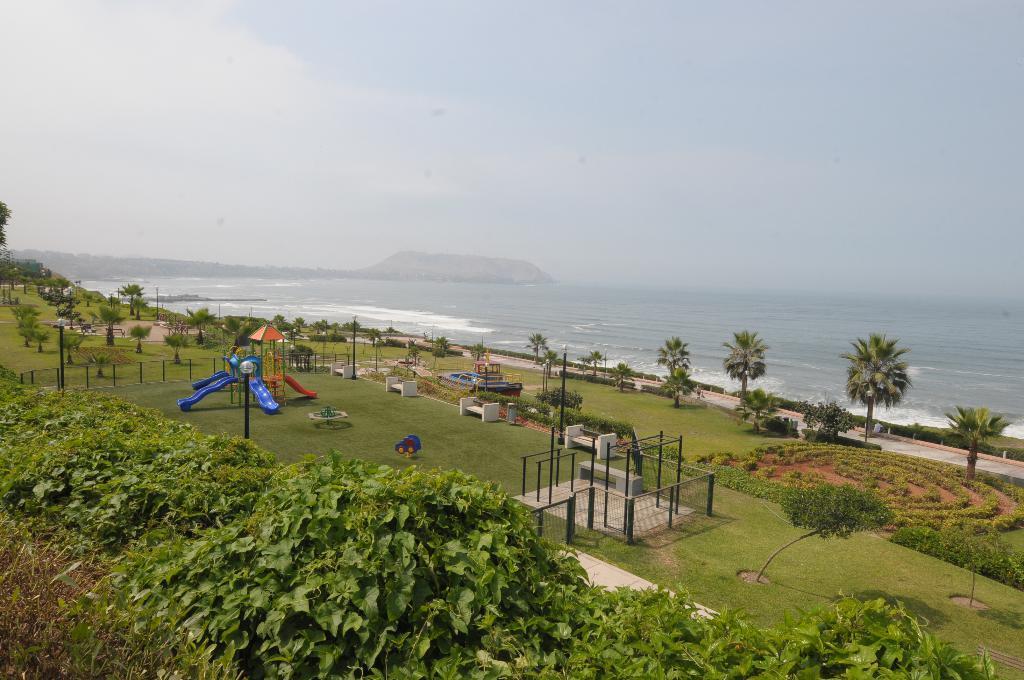Can you describe this image briefly? Here we can see plants,trees,grass,poles,benches and some playing objects for kids on the ground and light poles. In the background there are mountains,water and clouds in the sky. 